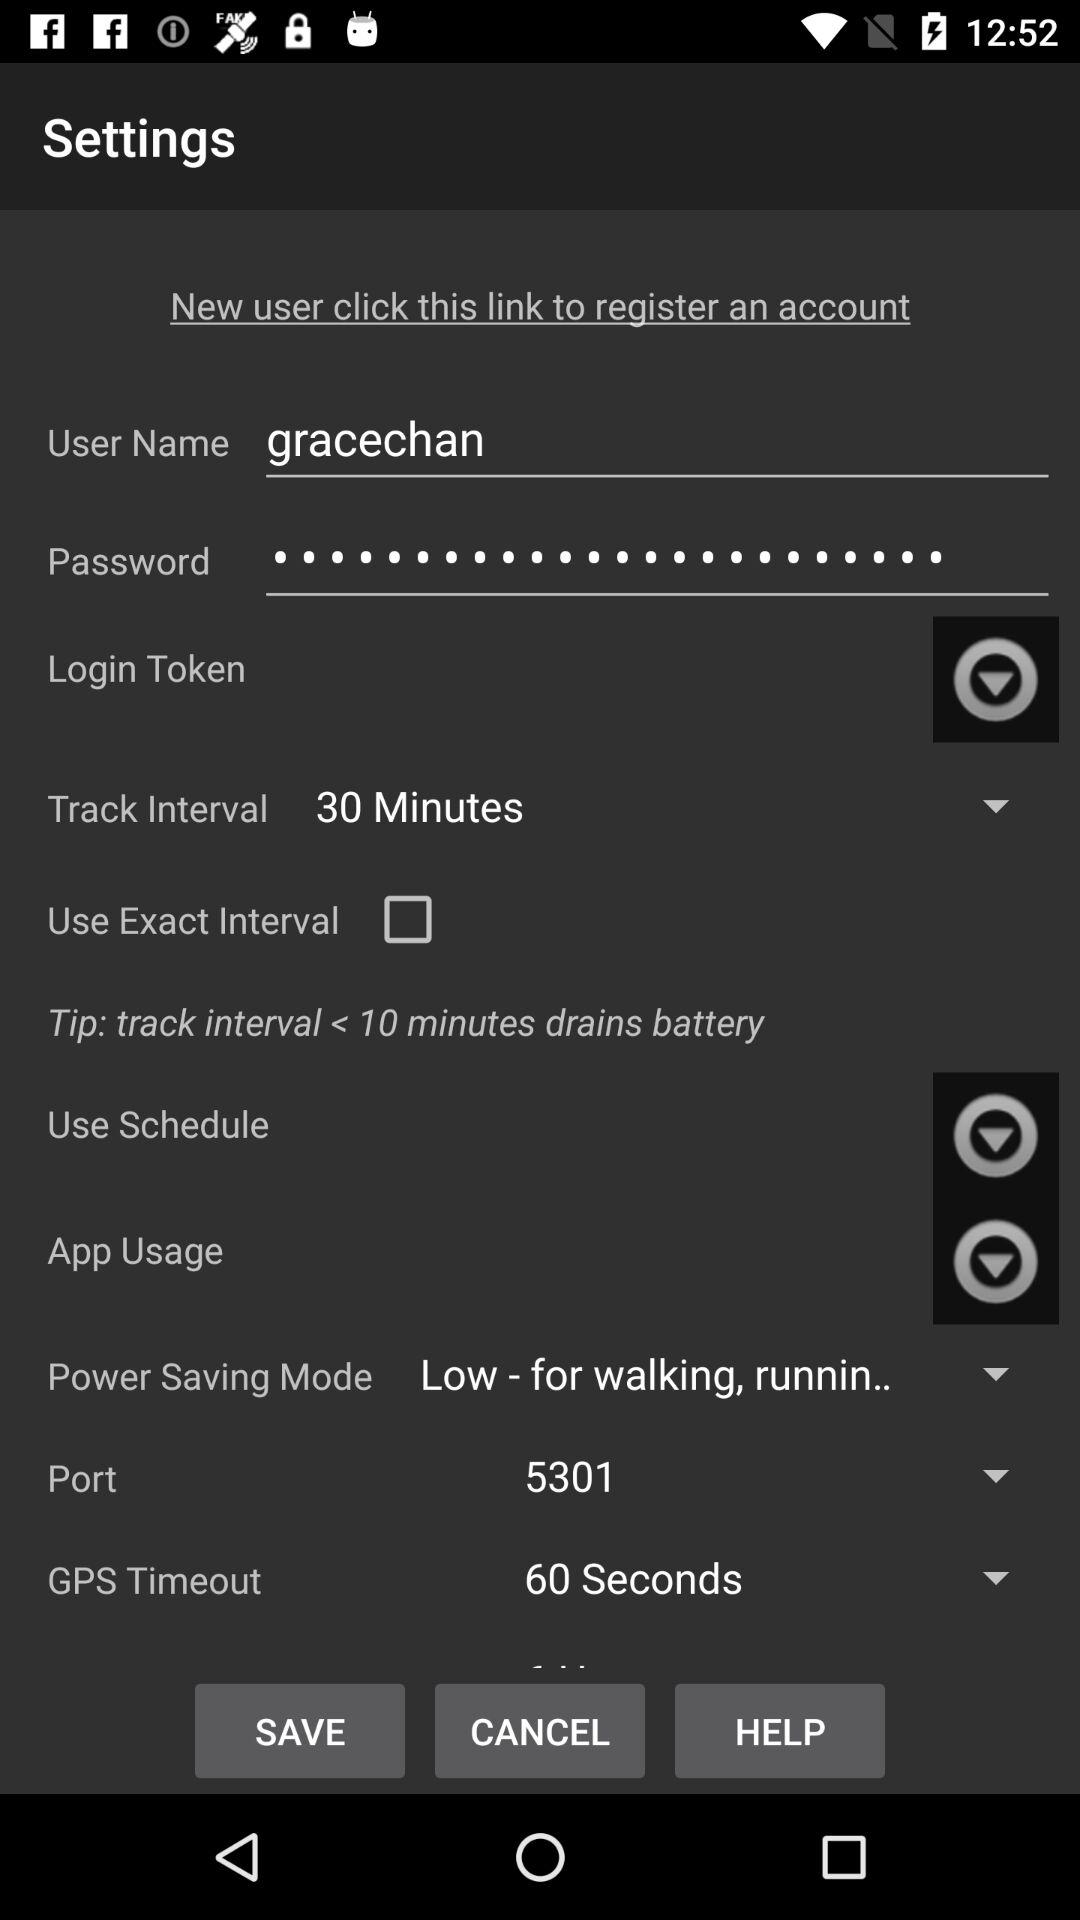What is the track interval time? The track interval time is 30 minutes. 